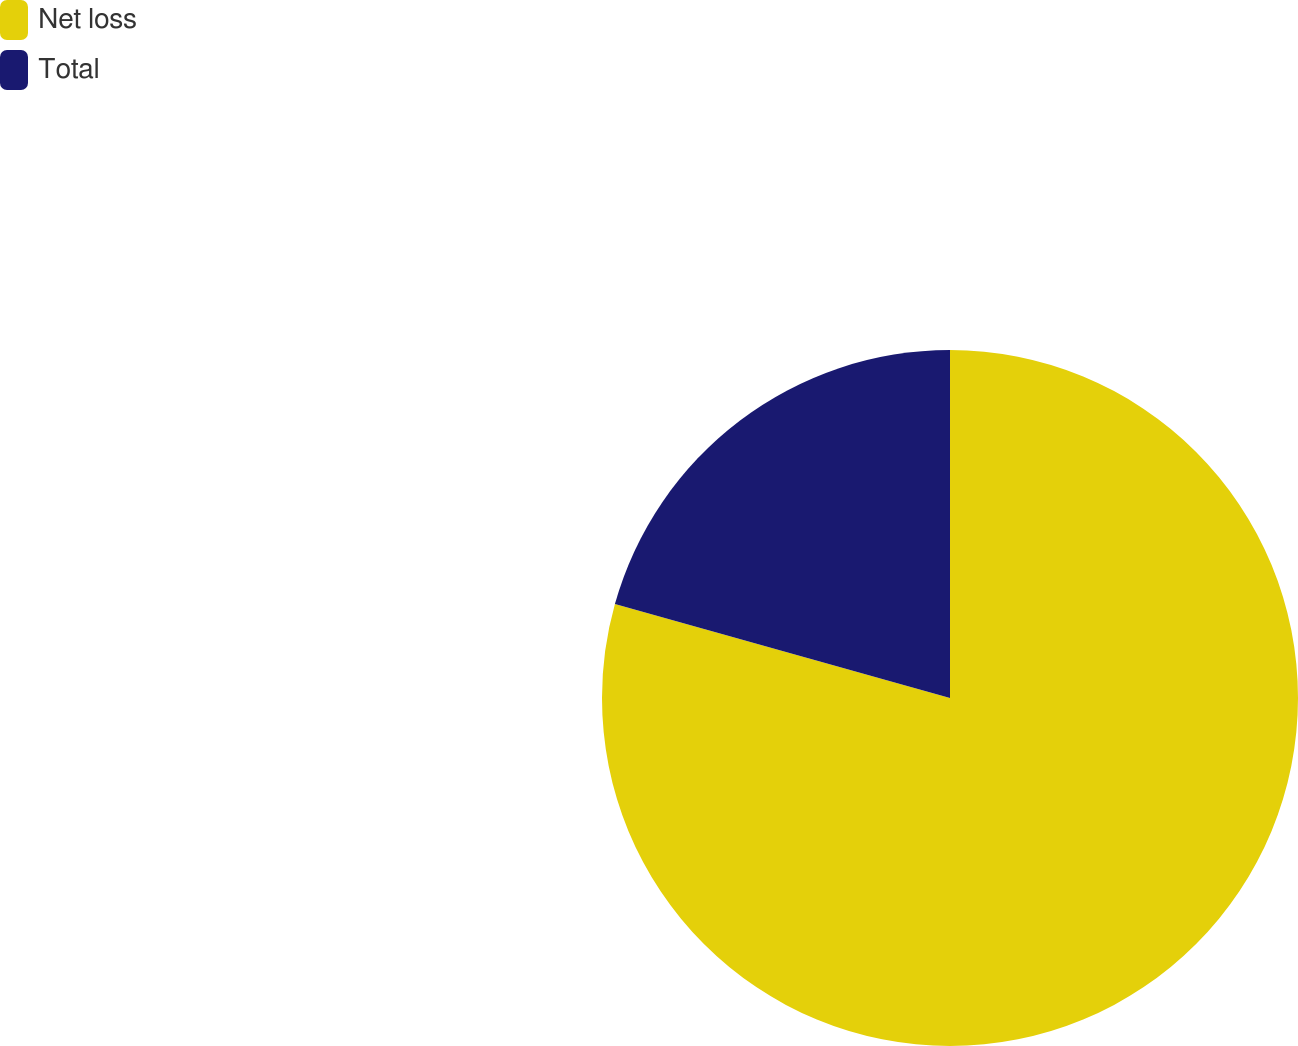<chart> <loc_0><loc_0><loc_500><loc_500><pie_chart><fcel>Net loss<fcel>Total<nl><fcel>79.35%<fcel>20.65%<nl></chart> 